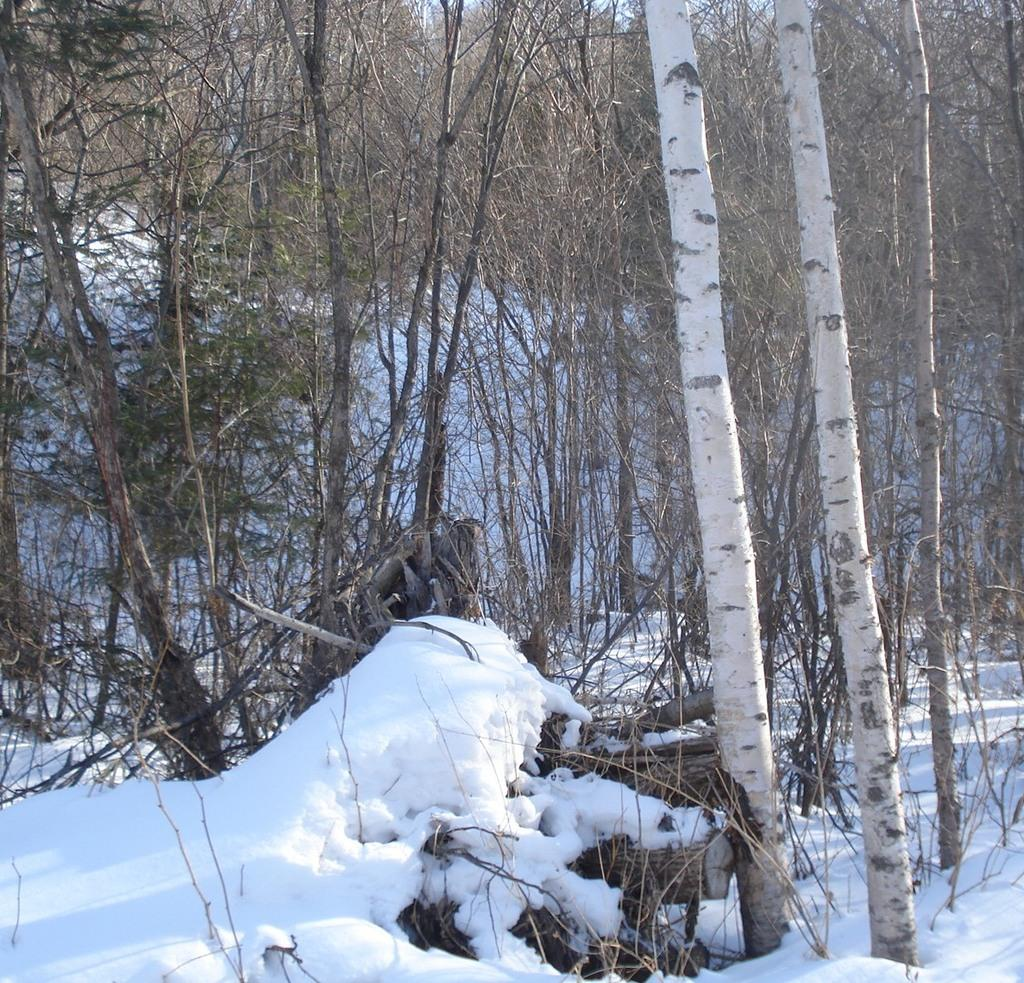What is covering the ground in the image? There is snow on the ground. What type of vegetation can be seen in the image? There are trees in the image. What title is written on the desk in the image? There is no desk present in the image, so there is no title written on it. 